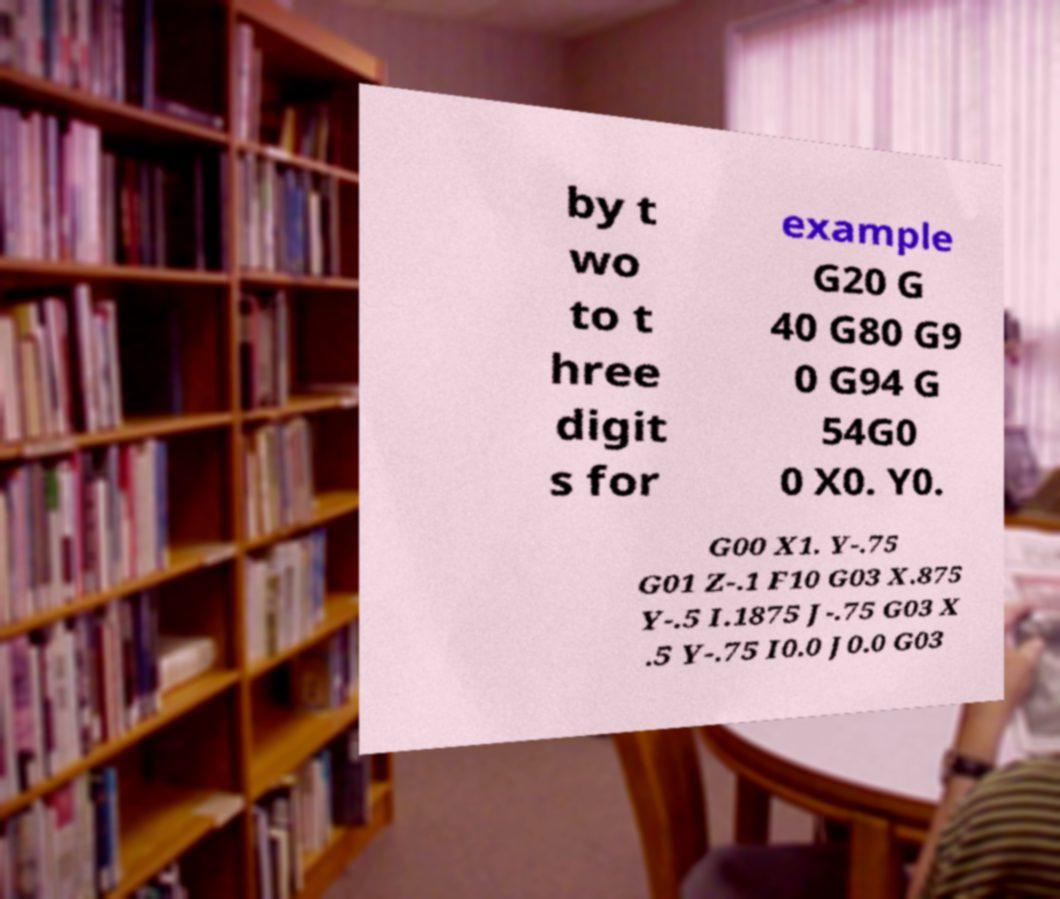Can you read and provide the text displayed in the image?This photo seems to have some interesting text. Can you extract and type it out for me? by t wo to t hree digit s for example G20 G 40 G80 G9 0 G94 G 54G0 0 X0. Y0. G00 X1. Y-.75 G01 Z-.1 F10 G03 X.875 Y-.5 I.1875 J-.75 G03 X .5 Y-.75 I0.0 J0.0 G03 